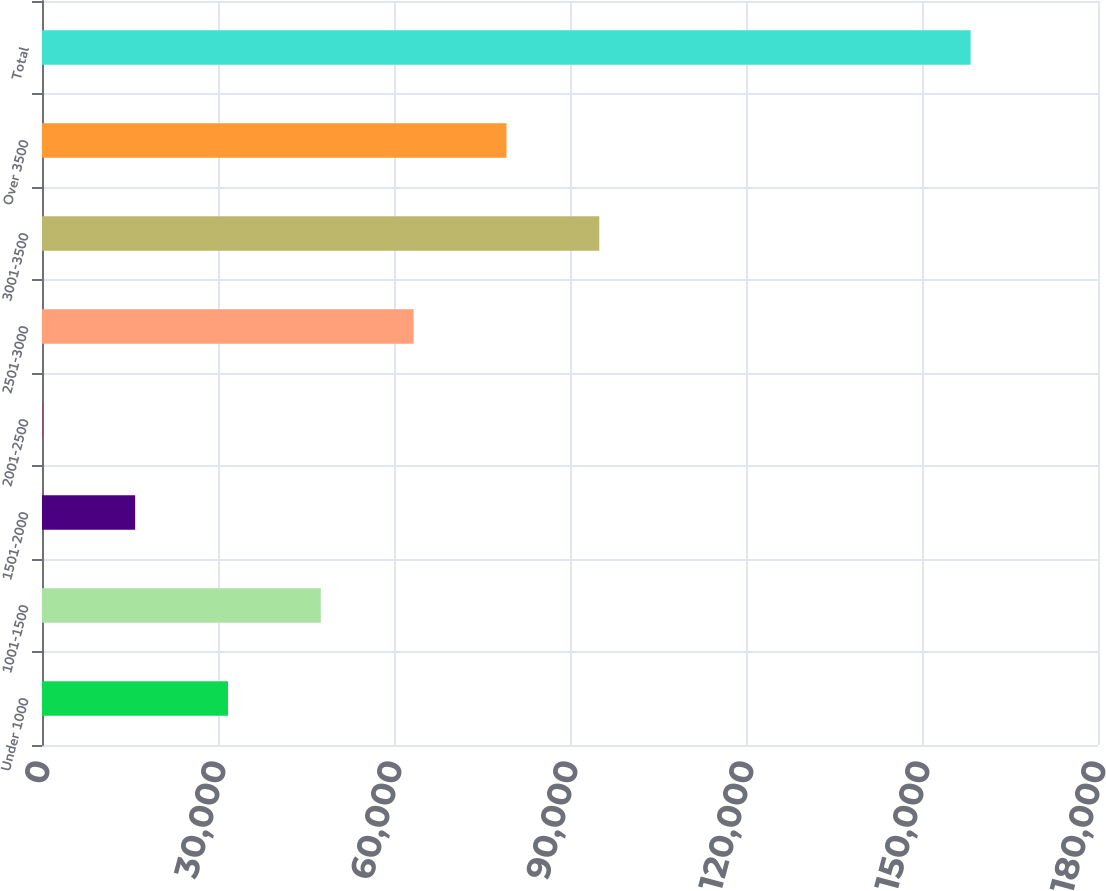Convert chart. <chart><loc_0><loc_0><loc_500><loc_500><bar_chart><fcel>Under 1000<fcel>1001-1500<fcel>1501-2000<fcel>2001-2500<fcel>2501-3000<fcel>3001-3500<fcel>Over 3500<fcel>Total<nl><fcel>31701.4<fcel>47524.6<fcel>15878.2<fcel>55<fcel>63347.8<fcel>94994.2<fcel>79171<fcel>158287<nl></chart> 